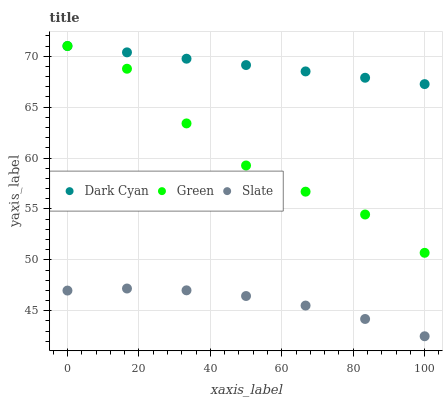Does Slate have the minimum area under the curve?
Answer yes or no. Yes. Does Dark Cyan have the maximum area under the curve?
Answer yes or no. Yes. Does Green have the minimum area under the curve?
Answer yes or no. No. Does Green have the maximum area under the curve?
Answer yes or no. No. Is Dark Cyan the smoothest?
Answer yes or no. Yes. Is Green the roughest?
Answer yes or no. Yes. Is Slate the smoothest?
Answer yes or no. No. Is Slate the roughest?
Answer yes or no. No. Does Slate have the lowest value?
Answer yes or no. Yes. Does Green have the lowest value?
Answer yes or no. No. Does Green have the highest value?
Answer yes or no. Yes. Does Slate have the highest value?
Answer yes or no. No. Is Slate less than Green?
Answer yes or no. Yes. Is Dark Cyan greater than Slate?
Answer yes or no. Yes. Does Dark Cyan intersect Green?
Answer yes or no. Yes. Is Dark Cyan less than Green?
Answer yes or no. No. Is Dark Cyan greater than Green?
Answer yes or no. No. Does Slate intersect Green?
Answer yes or no. No. 